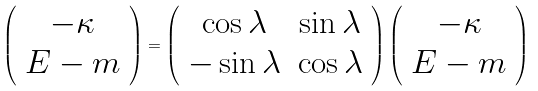<formula> <loc_0><loc_0><loc_500><loc_500>\left ( \begin{array} { c } - \kappa \\ E - m \end{array} \right ) = \left ( \begin{array} { c c } \cos \lambda & \sin \lambda \\ - \sin \lambda & \cos \lambda \end{array} \right ) \left ( \begin{array} { c } - \kappa \\ E - m \end{array} \right )</formula> 